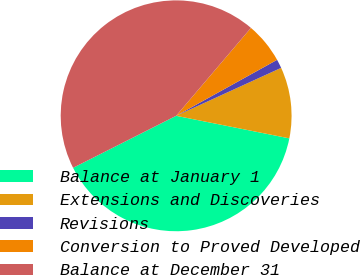<chart> <loc_0><loc_0><loc_500><loc_500><pie_chart><fcel>Balance at January 1<fcel>Extensions and Discoveries<fcel>Revisions<fcel>Conversion to Proved Developed<fcel>Balance at December 31<nl><fcel>39.43%<fcel>9.95%<fcel>1.24%<fcel>5.72%<fcel>43.66%<nl></chart> 